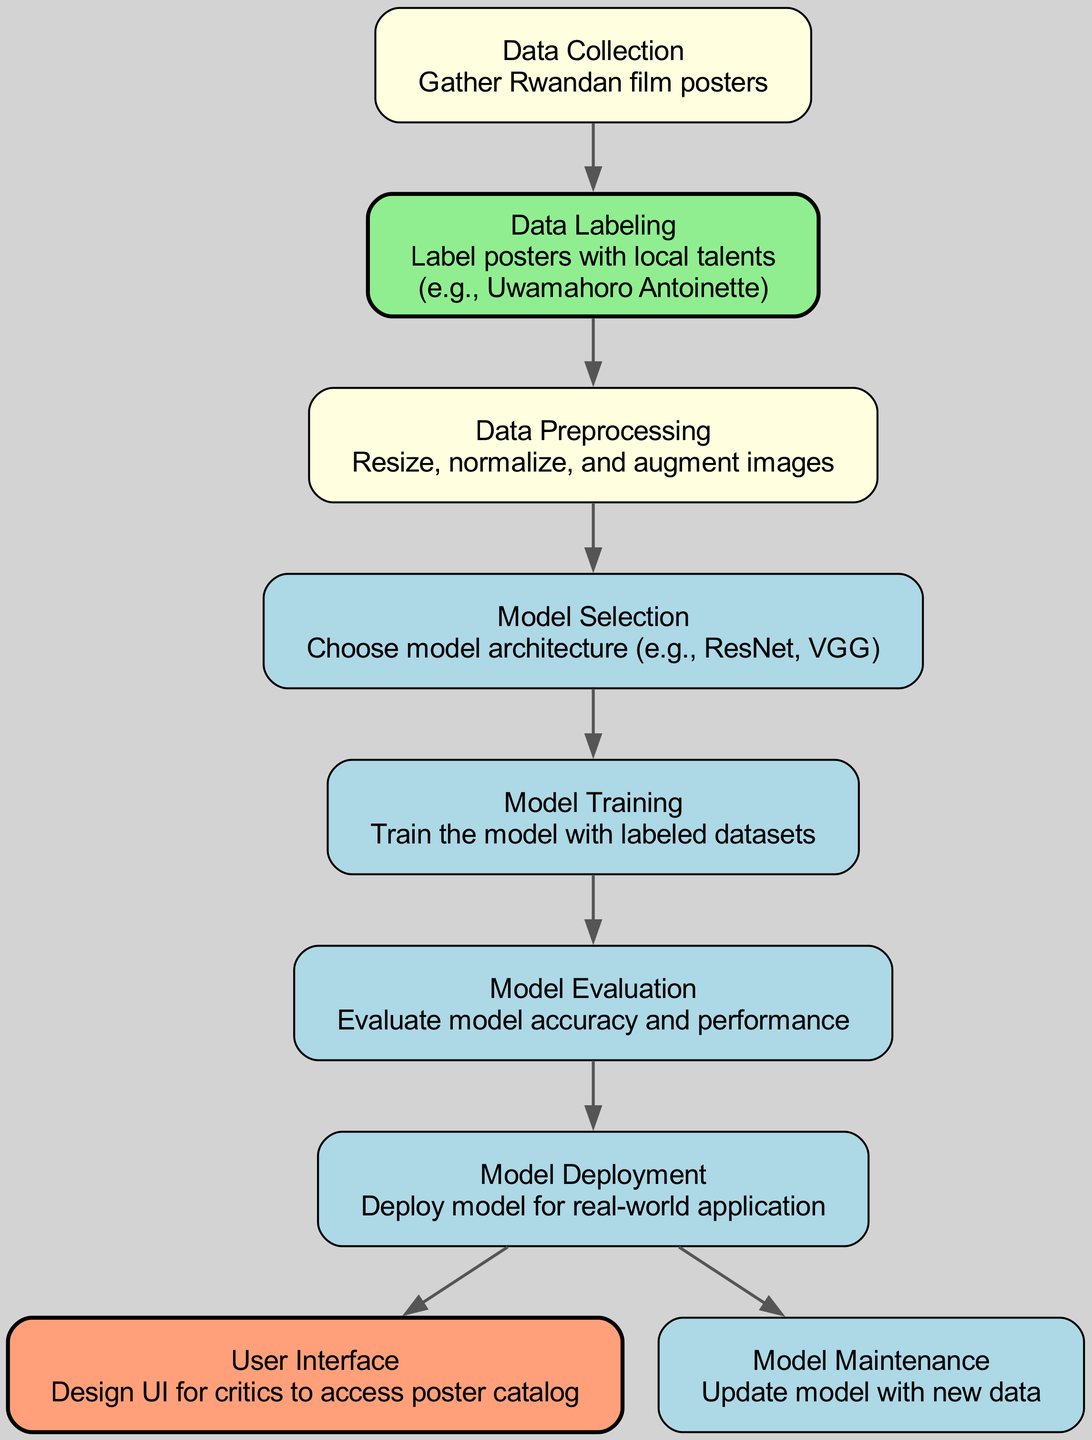What is the starting point of the model's process? The starting point of the process is the "Data Collection" node, where the gathering of Rwandan film posters begins.
Answer: Data Collection How many nodes are present in the diagram? By counting each unique operation represented in the diagram, we find there are a total of 9 nodes.
Answer: 9 Which node comes after Data Labeling? Following the "Data Labeling" node, the next step in the process is "Data Preprocessing."
Answer: Data Preprocessing What color indicates the "User Interface" node? The "User Interface" node is represented in a lightsalmon fill color according to the diagram's color scheme.
Answer: lightsalmon What is the main purpose of the Model Evaluation node? The purpose of the "Model Evaluation" node is to evaluate the model's accuracy and performance after training is complete.
Answer: Evaluate model accuracy and performance After which node is the Model Deployment performed? The "Model Deployment" occurs after the "Model Evaluation" node, which ensures the model is ready for real-world application.
Answer: Model Evaluation How many edges are there in the diagram? By counting the connections between the nodes, we find that there are 8 edges in total linking various steps of the process.
Answer: 8 Which node is emphasized in green and why? The "Data Labeling" node is emphasized in green because it highlights the importance of local talents in the labeling process.
Answer: Data Labeling What is the final step that follows the deployment of the model? The final step following the "Model Deployment" is "Model Maintenance," which involves updating the model with new data as it becomes available.
Answer: Model Maintenance 